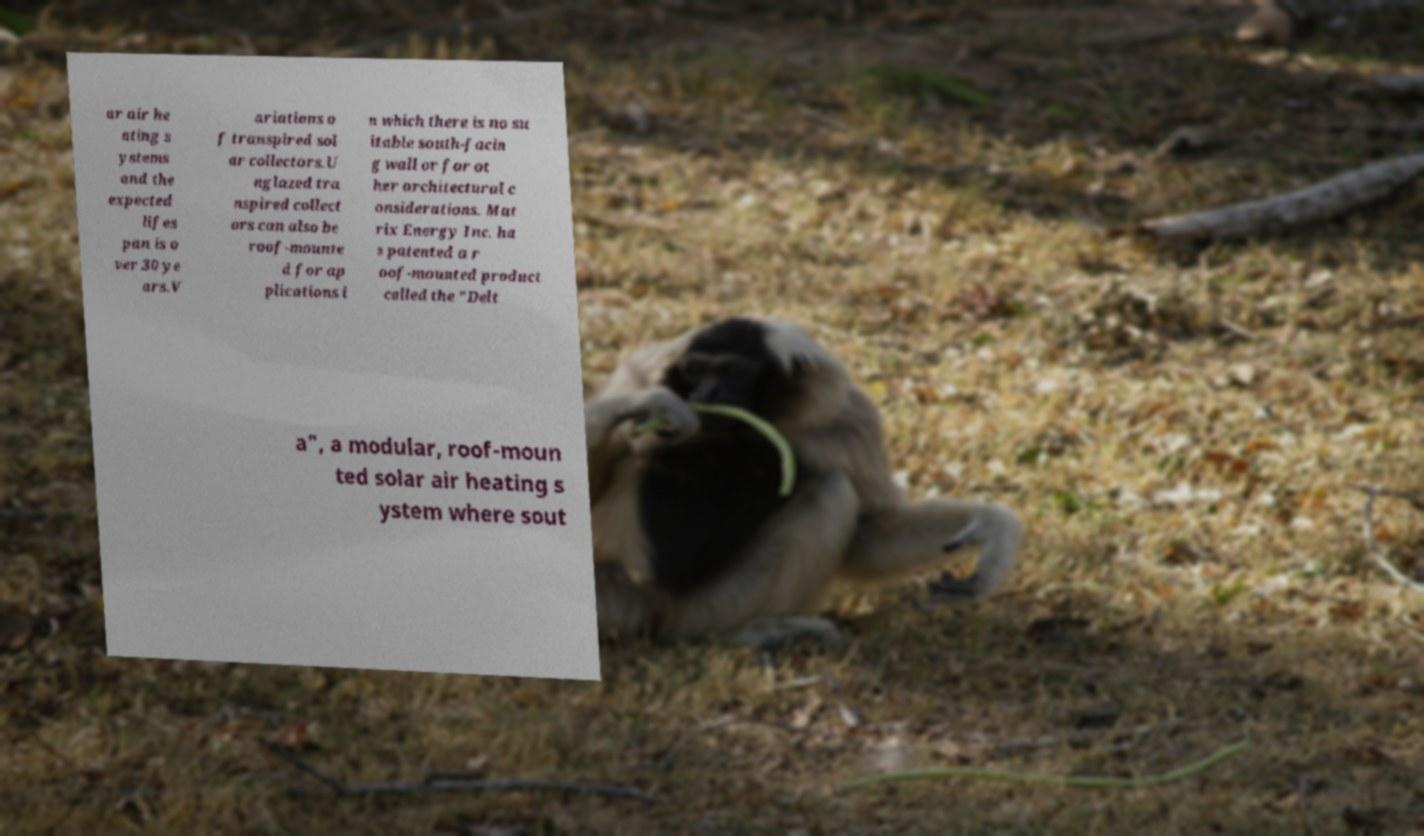What messages or text are displayed in this image? I need them in a readable, typed format. ar air he ating s ystems and the expected lifes pan is o ver 30 ye ars.V ariations o f transpired sol ar collectors.U nglazed tra nspired collect ors can also be roof-mounte d for ap plications i n which there is no su itable south-facin g wall or for ot her architectural c onsiderations. Mat rix Energy Inc. ha s patented a r oof-mounted product called the "Delt a", a modular, roof-moun ted solar air heating s ystem where sout 